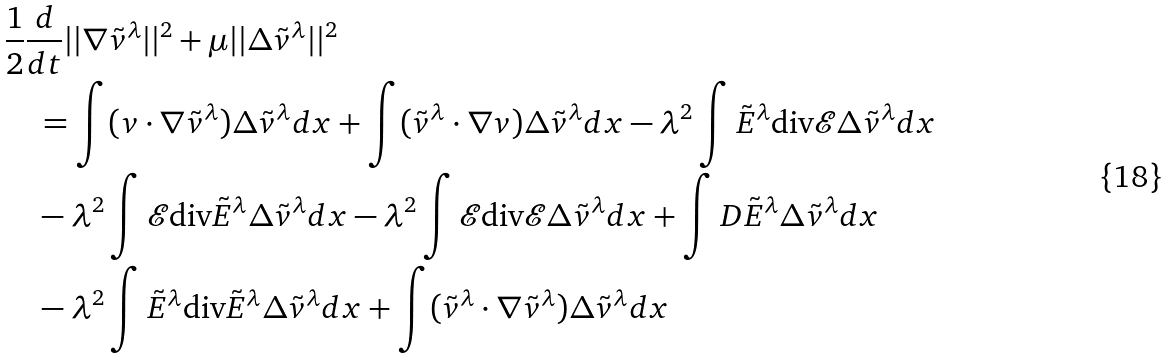<formula> <loc_0><loc_0><loc_500><loc_500>& \frac { 1 } { 2 } \frac { d } { d t } | | \nabla \tilde { v } ^ { \lambda } | | ^ { 2 } + \mu | | \Delta \tilde { v } ^ { \lambda } | | ^ { 2 } \\ & \quad = \int ( v \cdot \nabla \tilde { v } ^ { \lambda } ) \Delta \tilde { v } ^ { \lambda } d x + \int ( \tilde { v } ^ { \lambda } \cdot \nabla { v } ) \Delta \tilde { v } ^ { \lambda } d x - \lambda ^ { 2 } \int \tilde { E } ^ { \lambda } \text {div} \mathcal { E } \Delta \tilde { v } ^ { \lambda } d x \\ & \quad - \lambda ^ { 2 } \int \mathcal { E } \text {div} \tilde { E } ^ { \lambda } \Delta \tilde { v } ^ { \lambda } d x - \lambda ^ { 2 } \int \mathcal { E } \text {div} \mathcal { E } \Delta \tilde { v } ^ { \lambda } d x + \int D \tilde { E } ^ { \lambda } \Delta \tilde { v } ^ { \lambda } d x \\ & \quad - \lambda ^ { 2 } \int \tilde { E } ^ { \lambda } \text {div} \tilde { E } ^ { \lambda } \Delta \tilde { v } ^ { \lambda } d x + \int ( \tilde { v } ^ { \lambda } \cdot \nabla \tilde { v } ^ { \lambda } ) \Delta \tilde { v } ^ { \lambda } d x</formula> 